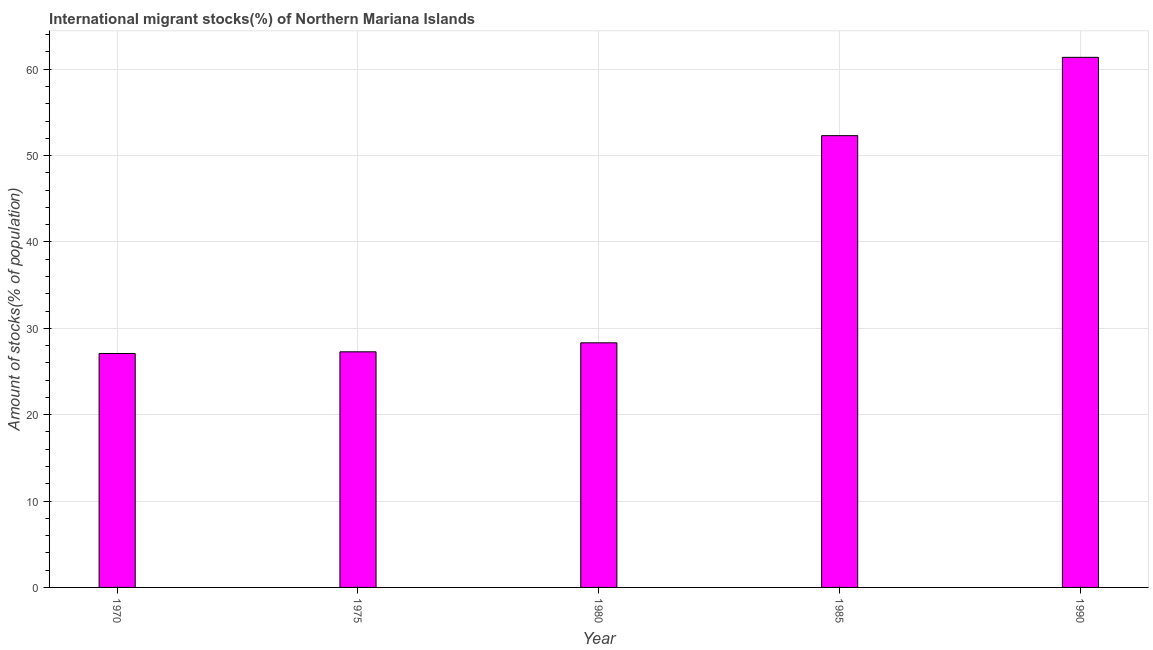Does the graph contain any zero values?
Provide a succinct answer. No. What is the title of the graph?
Offer a very short reply. International migrant stocks(%) of Northern Mariana Islands. What is the label or title of the Y-axis?
Offer a very short reply. Amount of stocks(% of population). What is the number of international migrant stocks in 1990?
Provide a succinct answer. 61.38. Across all years, what is the maximum number of international migrant stocks?
Provide a short and direct response. 61.38. Across all years, what is the minimum number of international migrant stocks?
Your response must be concise. 27.08. In which year was the number of international migrant stocks minimum?
Ensure brevity in your answer.  1970. What is the sum of the number of international migrant stocks?
Give a very brief answer. 196.36. What is the difference between the number of international migrant stocks in 1970 and 1975?
Your response must be concise. -0.19. What is the average number of international migrant stocks per year?
Ensure brevity in your answer.  39.27. What is the median number of international migrant stocks?
Offer a terse response. 28.32. What is the ratio of the number of international migrant stocks in 1975 to that in 1990?
Offer a very short reply. 0.44. Is the number of international migrant stocks in 1980 less than that in 1990?
Keep it short and to the point. Yes. Is the difference between the number of international migrant stocks in 1975 and 1980 greater than the difference between any two years?
Keep it short and to the point. No. What is the difference between the highest and the second highest number of international migrant stocks?
Ensure brevity in your answer.  9.07. Is the sum of the number of international migrant stocks in 1980 and 1985 greater than the maximum number of international migrant stocks across all years?
Provide a succinct answer. Yes. What is the difference between the highest and the lowest number of international migrant stocks?
Give a very brief answer. 34.29. How many bars are there?
Your response must be concise. 5. Are all the bars in the graph horizontal?
Offer a terse response. No. What is the Amount of stocks(% of population) in 1970?
Provide a short and direct response. 27.08. What is the Amount of stocks(% of population) in 1975?
Keep it short and to the point. 27.28. What is the Amount of stocks(% of population) in 1980?
Offer a terse response. 28.32. What is the Amount of stocks(% of population) of 1985?
Provide a short and direct response. 52.31. What is the Amount of stocks(% of population) of 1990?
Provide a short and direct response. 61.38. What is the difference between the Amount of stocks(% of population) in 1970 and 1975?
Provide a short and direct response. -0.19. What is the difference between the Amount of stocks(% of population) in 1970 and 1980?
Make the answer very short. -1.24. What is the difference between the Amount of stocks(% of population) in 1970 and 1985?
Your response must be concise. -25.22. What is the difference between the Amount of stocks(% of population) in 1970 and 1990?
Your answer should be very brief. -34.29. What is the difference between the Amount of stocks(% of population) in 1975 and 1980?
Keep it short and to the point. -1.04. What is the difference between the Amount of stocks(% of population) in 1975 and 1985?
Your answer should be compact. -25.03. What is the difference between the Amount of stocks(% of population) in 1975 and 1990?
Your answer should be compact. -34.1. What is the difference between the Amount of stocks(% of population) in 1980 and 1985?
Your answer should be compact. -23.99. What is the difference between the Amount of stocks(% of population) in 1980 and 1990?
Your answer should be compact. -33.06. What is the difference between the Amount of stocks(% of population) in 1985 and 1990?
Offer a very short reply. -9.07. What is the ratio of the Amount of stocks(% of population) in 1970 to that in 1980?
Make the answer very short. 0.96. What is the ratio of the Amount of stocks(% of population) in 1970 to that in 1985?
Make the answer very short. 0.52. What is the ratio of the Amount of stocks(% of population) in 1970 to that in 1990?
Provide a succinct answer. 0.44. What is the ratio of the Amount of stocks(% of population) in 1975 to that in 1985?
Offer a terse response. 0.52. What is the ratio of the Amount of stocks(% of population) in 1975 to that in 1990?
Offer a very short reply. 0.44. What is the ratio of the Amount of stocks(% of population) in 1980 to that in 1985?
Your answer should be very brief. 0.54. What is the ratio of the Amount of stocks(% of population) in 1980 to that in 1990?
Make the answer very short. 0.46. What is the ratio of the Amount of stocks(% of population) in 1985 to that in 1990?
Provide a succinct answer. 0.85. 